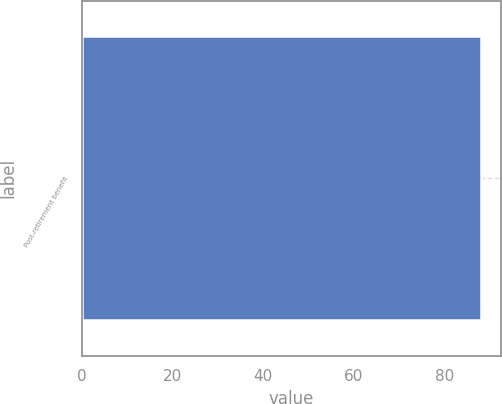Convert chart. <chart><loc_0><loc_0><loc_500><loc_500><bar_chart><fcel>Post-retirement benefit<nl><fcel>88<nl></chart> 